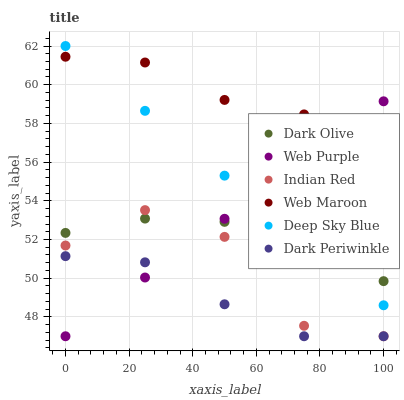Does Dark Periwinkle have the minimum area under the curve?
Answer yes or no. Yes. Does Web Maroon have the maximum area under the curve?
Answer yes or no. Yes. Does Dark Olive have the minimum area under the curve?
Answer yes or no. No. Does Dark Olive have the maximum area under the curve?
Answer yes or no. No. Is Web Purple the smoothest?
Answer yes or no. Yes. Is Indian Red the roughest?
Answer yes or no. Yes. Is Dark Olive the smoothest?
Answer yes or no. No. Is Dark Olive the roughest?
Answer yes or no. No. Does Indian Red have the lowest value?
Answer yes or no. Yes. Does Dark Olive have the lowest value?
Answer yes or no. No. Does Deep Sky Blue have the highest value?
Answer yes or no. Yes. Does Dark Olive have the highest value?
Answer yes or no. No. Is Dark Periwinkle less than Dark Olive?
Answer yes or no. Yes. Is Dark Olive greater than Dark Periwinkle?
Answer yes or no. Yes. Does Web Purple intersect Deep Sky Blue?
Answer yes or no. Yes. Is Web Purple less than Deep Sky Blue?
Answer yes or no. No. Is Web Purple greater than Deep Sky Blue?
Answer yes or no. No. Does Dark Periwinkle intersect Dark Olive?
Answer yes or no. No. 